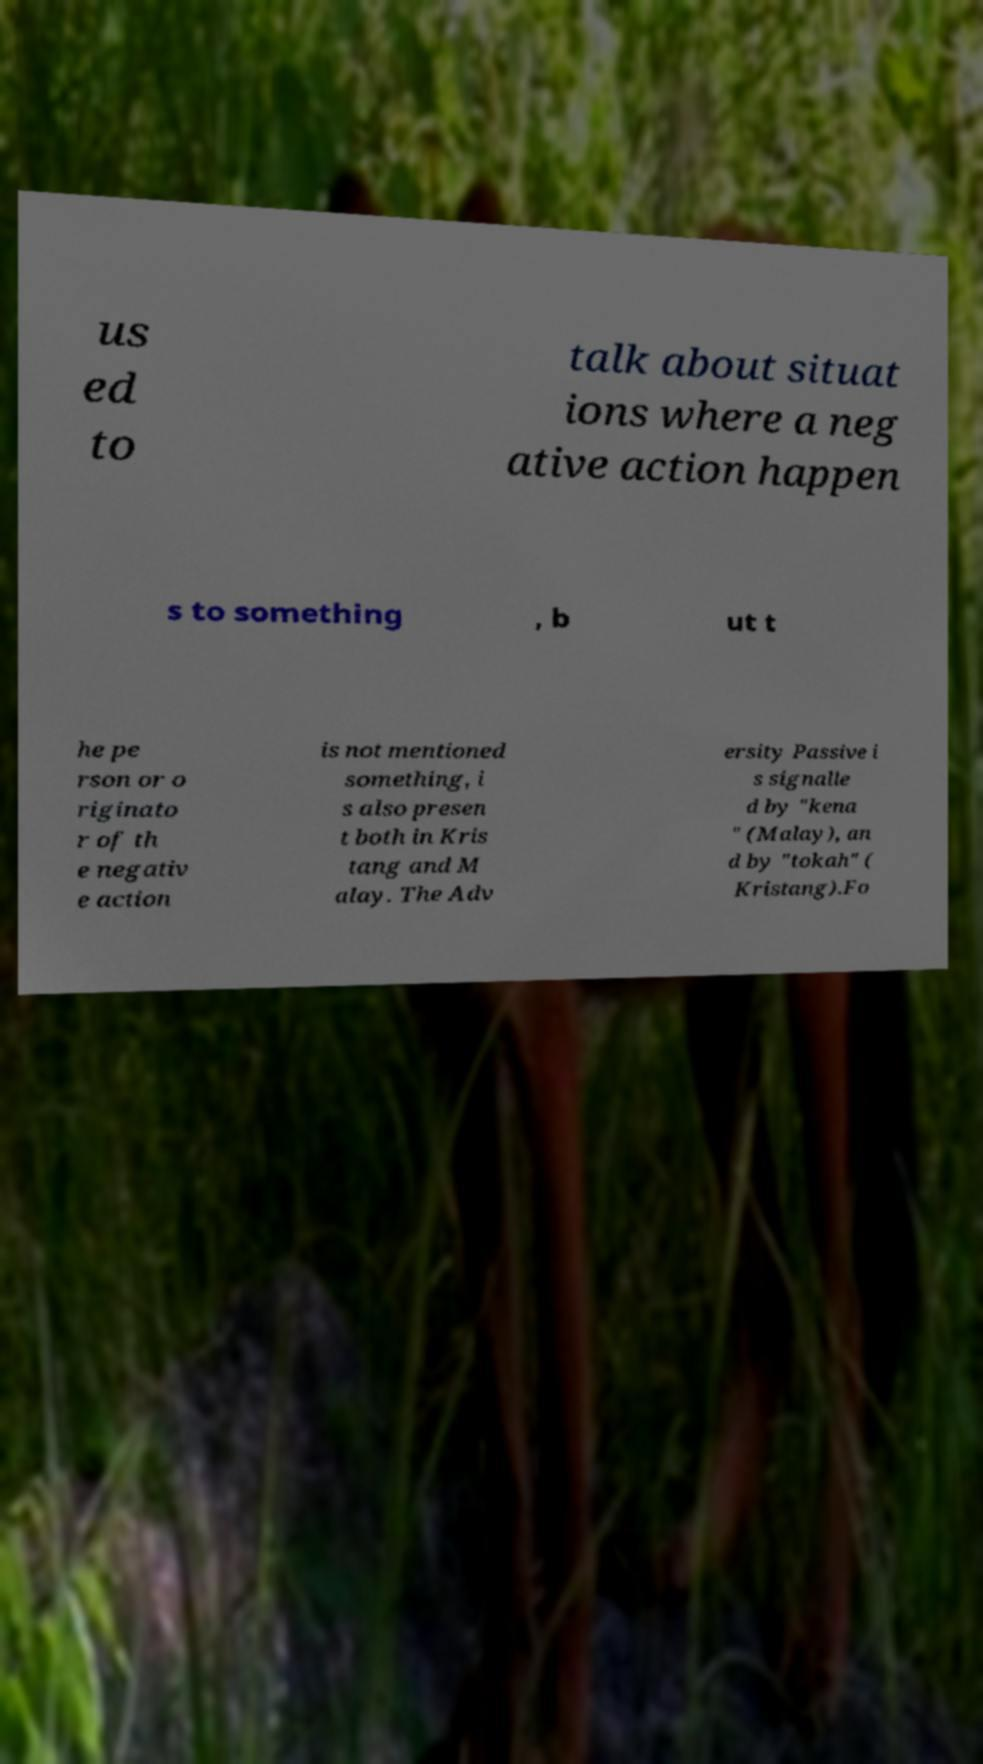Could you assist in decoding the text presented in this image and type it out clearly? us ed to talk about situat ions where a neg ative action happen s to something , b ut t he pe rson or o riginato r of th e negativ e action is not mentioned something, i s also presen t both in Kris tang and M alay. The Adv ersity Passive i s signalle d by "kena " (Malay), an d by "tokah" ( Kristang).Fo 